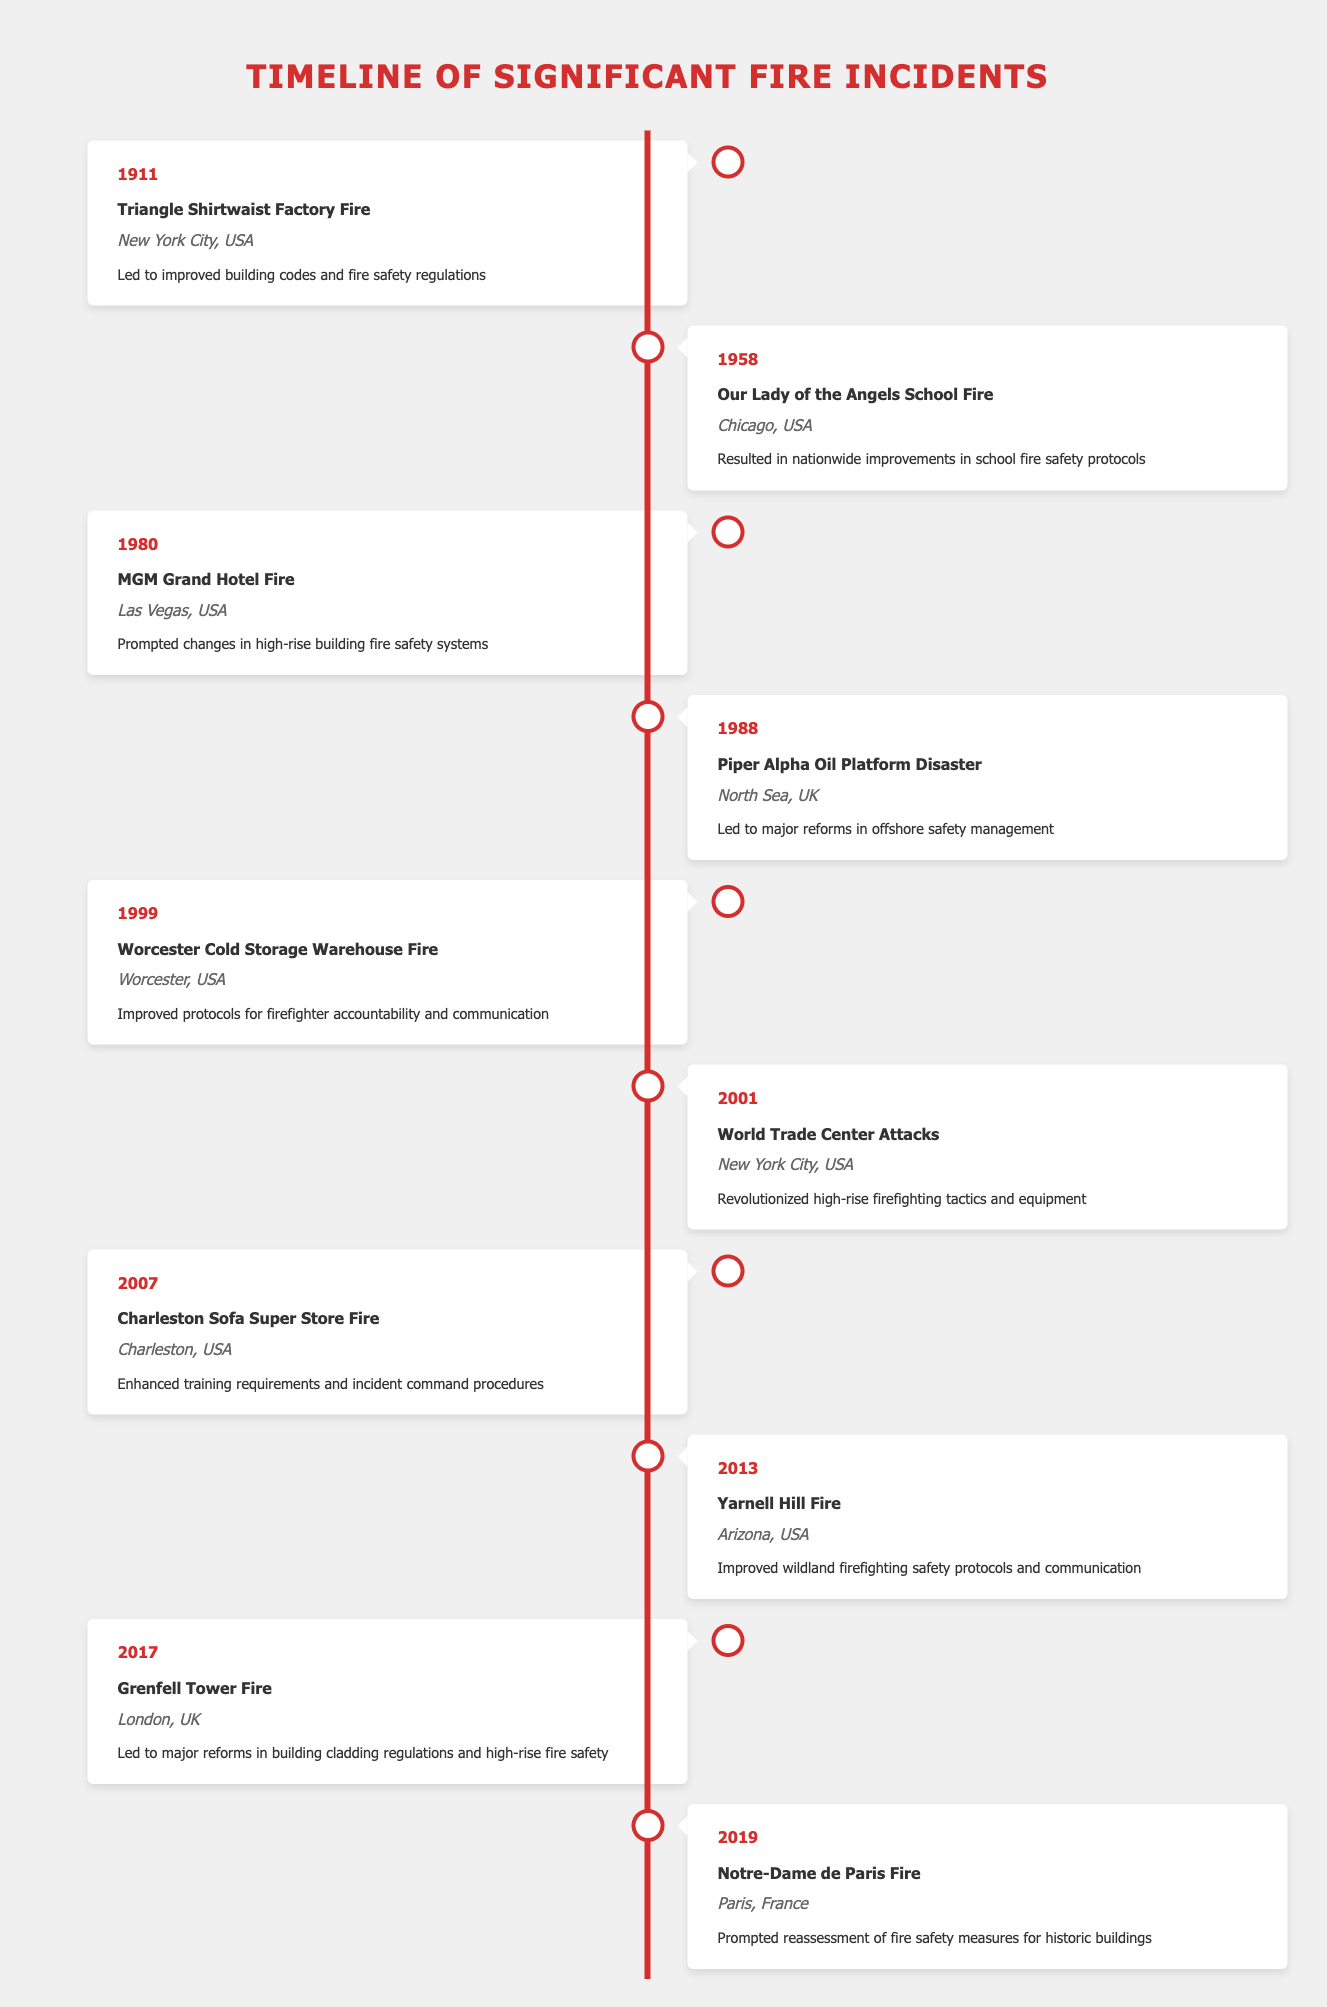What significant event occurred in 1911 that influenced firefighter safety regulations? The 1911 Triangle Shirtwaist Factory Fire led to improved building codes and fire safety regulations, highlighting the need for better safety measures in buildings.
Answer: Triangle Shirtwaist Factory Fire How many incidents in the timeline led to changes related to high-rise fire safety? There are two incidents related to high-rise safety: the MGM Grand Hotel Fire in 1980 and the World Trade Center Attacks in 2001.
Answer: Two What was the impact of the 2007 Charleston Sofa Super Store Fire? The Charleston Sofa Super Store Fire led to enhanced training requirements and incident command procedures, improving firefighter preparedness and management during incidents.
Answer: Enhanced training requirements Which fire incident in the timeline resulted in improvements specifically for school fire safety protocols? The Our Lady of the Angels School Fire in 1958 resulted in nationwide improvements in school fire safety protocols, aiming to protect children in educational settings.
Answer: Our Lady of the Angels School Fire True or False: The Grenfell Tower Fire occurred before the Yarnell Hill Fire. The Grenfell Tower Fire happened in 2017, and the Yarnell Hill Fire occurred in 2013, so the statement is false as Grenfell came after Yarnell.
Answer: False What year saw the largest impact on firefighter accountability and communication in the timeline? The Worcester Cold Storage Warehouse Fire in 1999 significantly improved protocols for firefighter accountability and communication, indicating a crucial shift in managing fire incidents.
Answer: 1999 How did the Piper Alpha Oil Platform Disaster influence offshore safety management? The 1988 Piper Alpha Oil Platform Disaster led to major reforms in offshore safety management, underscoring the importance of safety protocols in high-risk environments such as oil platforms.
Answer: Major reforms in offshore safety management Which incidents occurred in New York City, and what were their impacts? Two incidents occurred in New York City: the Triangle Shirtwaist Factory Fire in 1911 (improved building codes) and the World Trade Center Attacks in 2001 (revolutionized high-rise firefighting tactics).
Answer: Triangle Shirtwaist Factory Fire and World Trade Center Attacks How many incidents occurred in the 21st century on the timeline? There are four incidents in the 21st century: the World Trade Center Attacks in 2001, the Charleston Sofa Super Store Fire in 2007, the Yarnell Hill Fire in 2013, and the Grenfell Tower Fire in 2017.
Answer: Four 